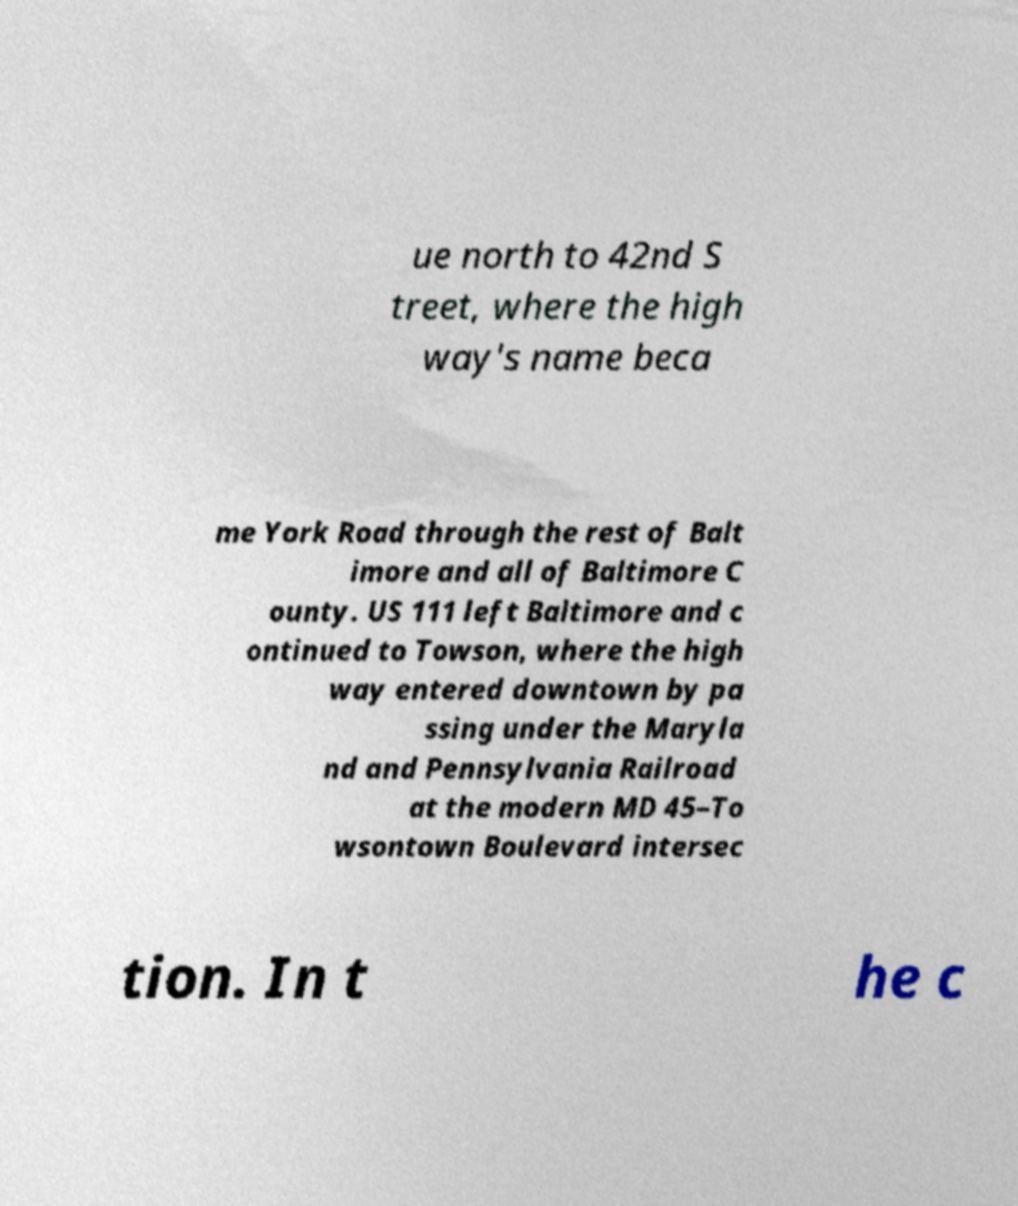What messages or text are displayed in this image? I need them in a readable, typed format. ue north to 42nd S treet, where the high way's name beca me York Road through the rest of Balt imore and all of Baltimore C ounty. US 111 left Baltimore and c ontinued to Towson, where the high way entered downtown by pa ssing under the Maryla nd and Pennsylvania Railroad at the modern MD 45–To wsontown Boulevard intersec tion. In t he c 